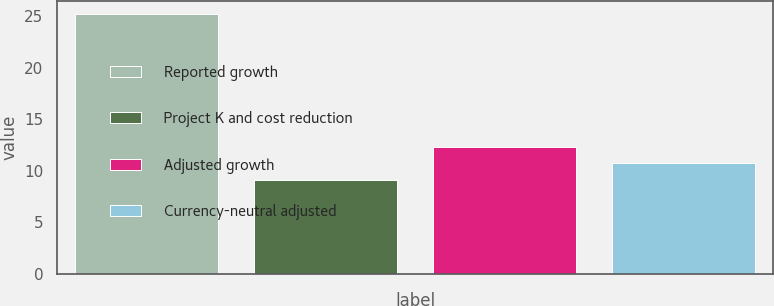Convert chart. <chart><loc_0><loc_0><loc_500><loc_500><bar_chart><fcel>Reported growth<fcel>Project K and cost reduction<fcel>Adjusted growth<fcel>Currency-neutral adjusted<nl><fcel>25.2<fcel>9.1<fcel>12.32<fcel>10.71<nl></chart> 